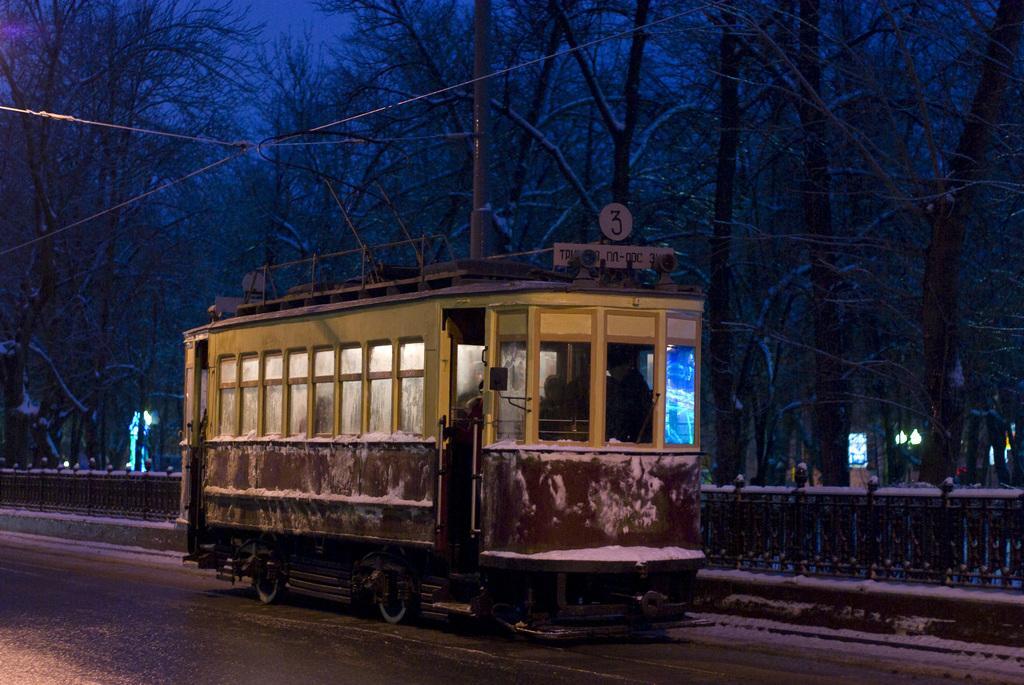Describe this image in one or two sentences. In the center of the image there is a bus and we can see people sitting in the bus. In the background there are trees and pole. At the bottom we can see a fence and snow. 